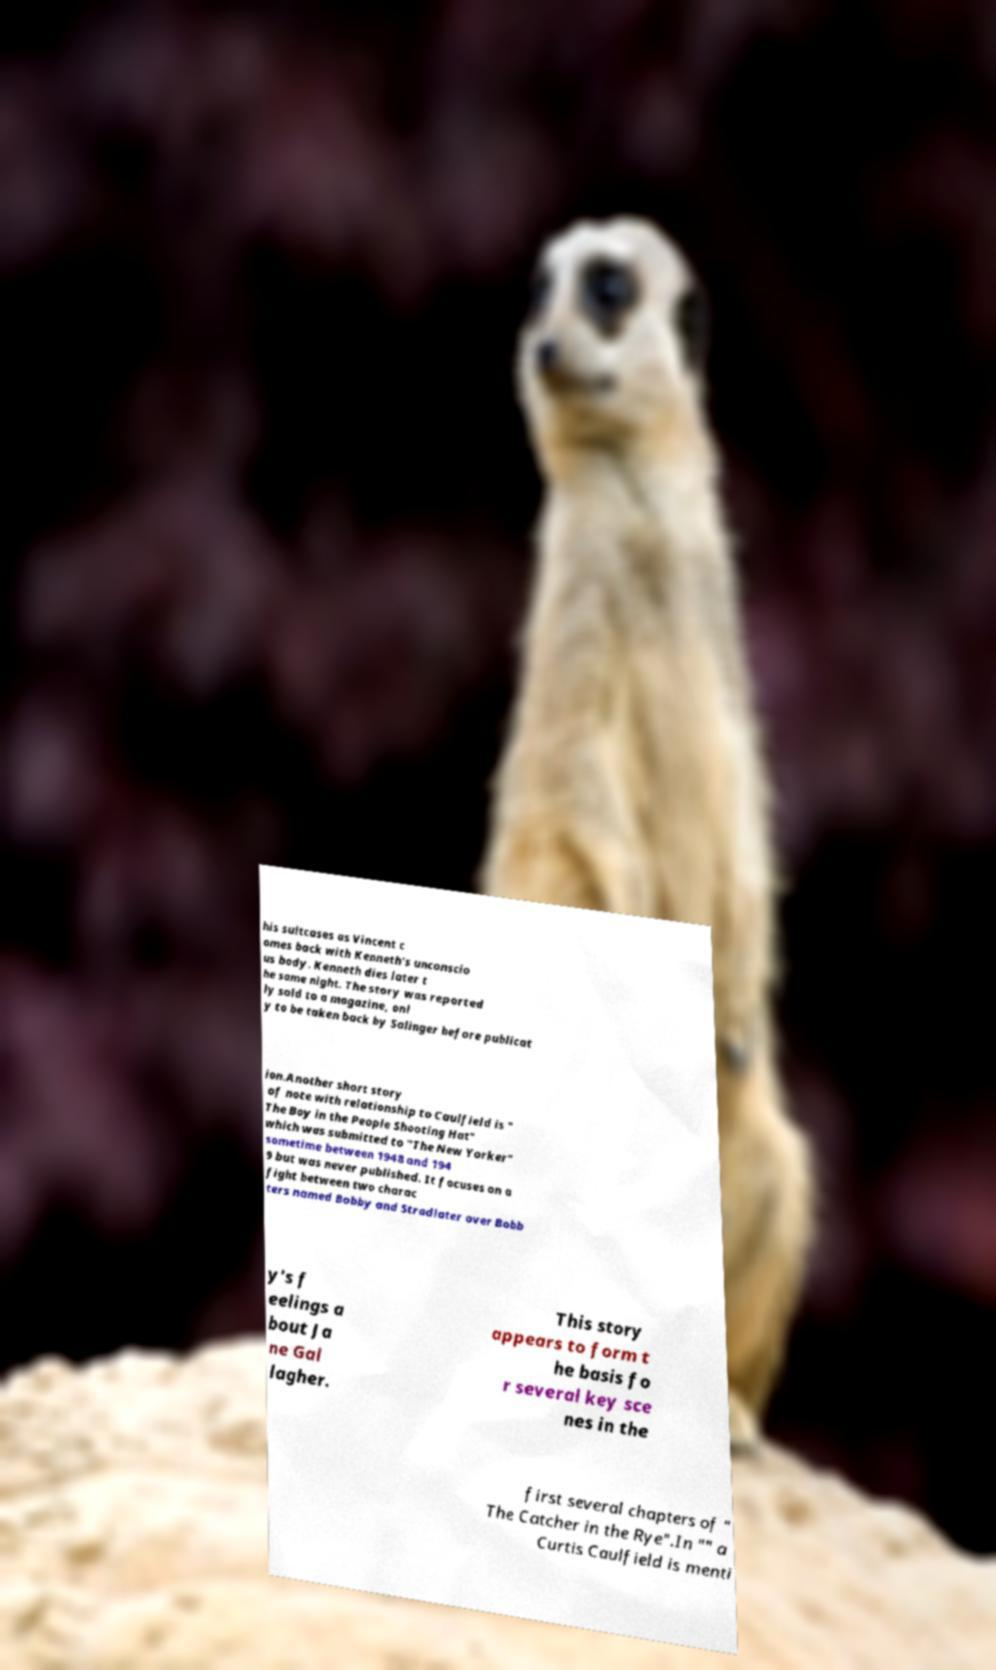Can you accurately transcribe the text from the provided image for me? his suitcases as Vincent c omes back with Kenneth's unconscio us body. Kenneth dies later t he same night. The story was reported ly sold to a magazine, onl y to be taken back by Salinger before publicat ion.Another short story of note with relationship to Caulfield is " The Boy in the People Shooting Hat" which was submitted to "The New Yorker" sometime between 1948 and 194 9 but was never published. It focuses on a fight between two charac ters named Bobby and Stradlater over Bobb y's f eelings a bout Ja ne Gal lagher. This story appears to form t he basis fo r several key sce nes in the first several chapters of " The Catcher in the Rye".In "" a Curtis Caulfield is menti 